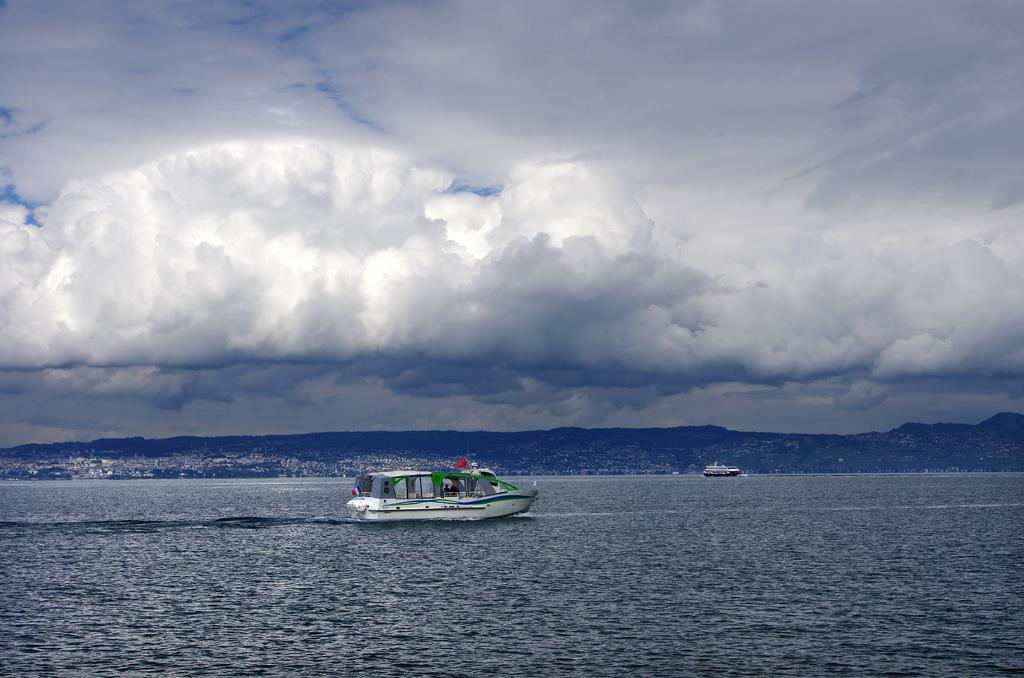What is the main subject of the image? The main subject of the image is a ship. What is the ship doing in the image? The ship is moving in the water. What can be seen in the sky in the image? There are clouds visible in the image. What is the purpose of the flesh in the image? There is no flesh present in the image; it features a ship moving in the water with clouds visible in the sky. 